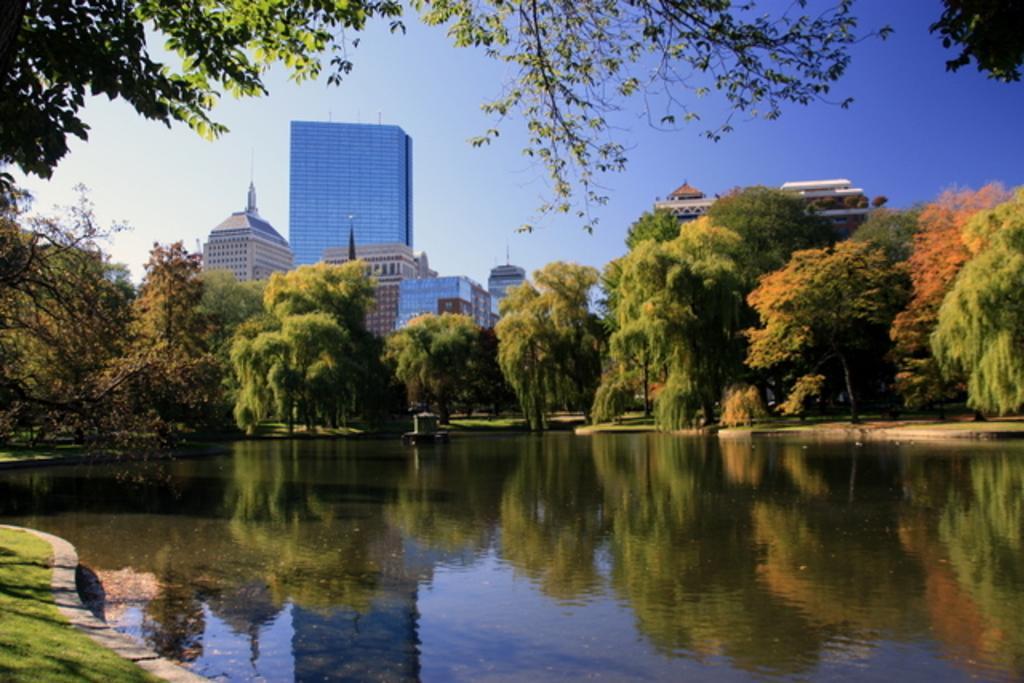Could you give a brief overview of what you see in this image? In the image there is a lake in the front with trees behind it and over the background there are buildings and above its sky. 